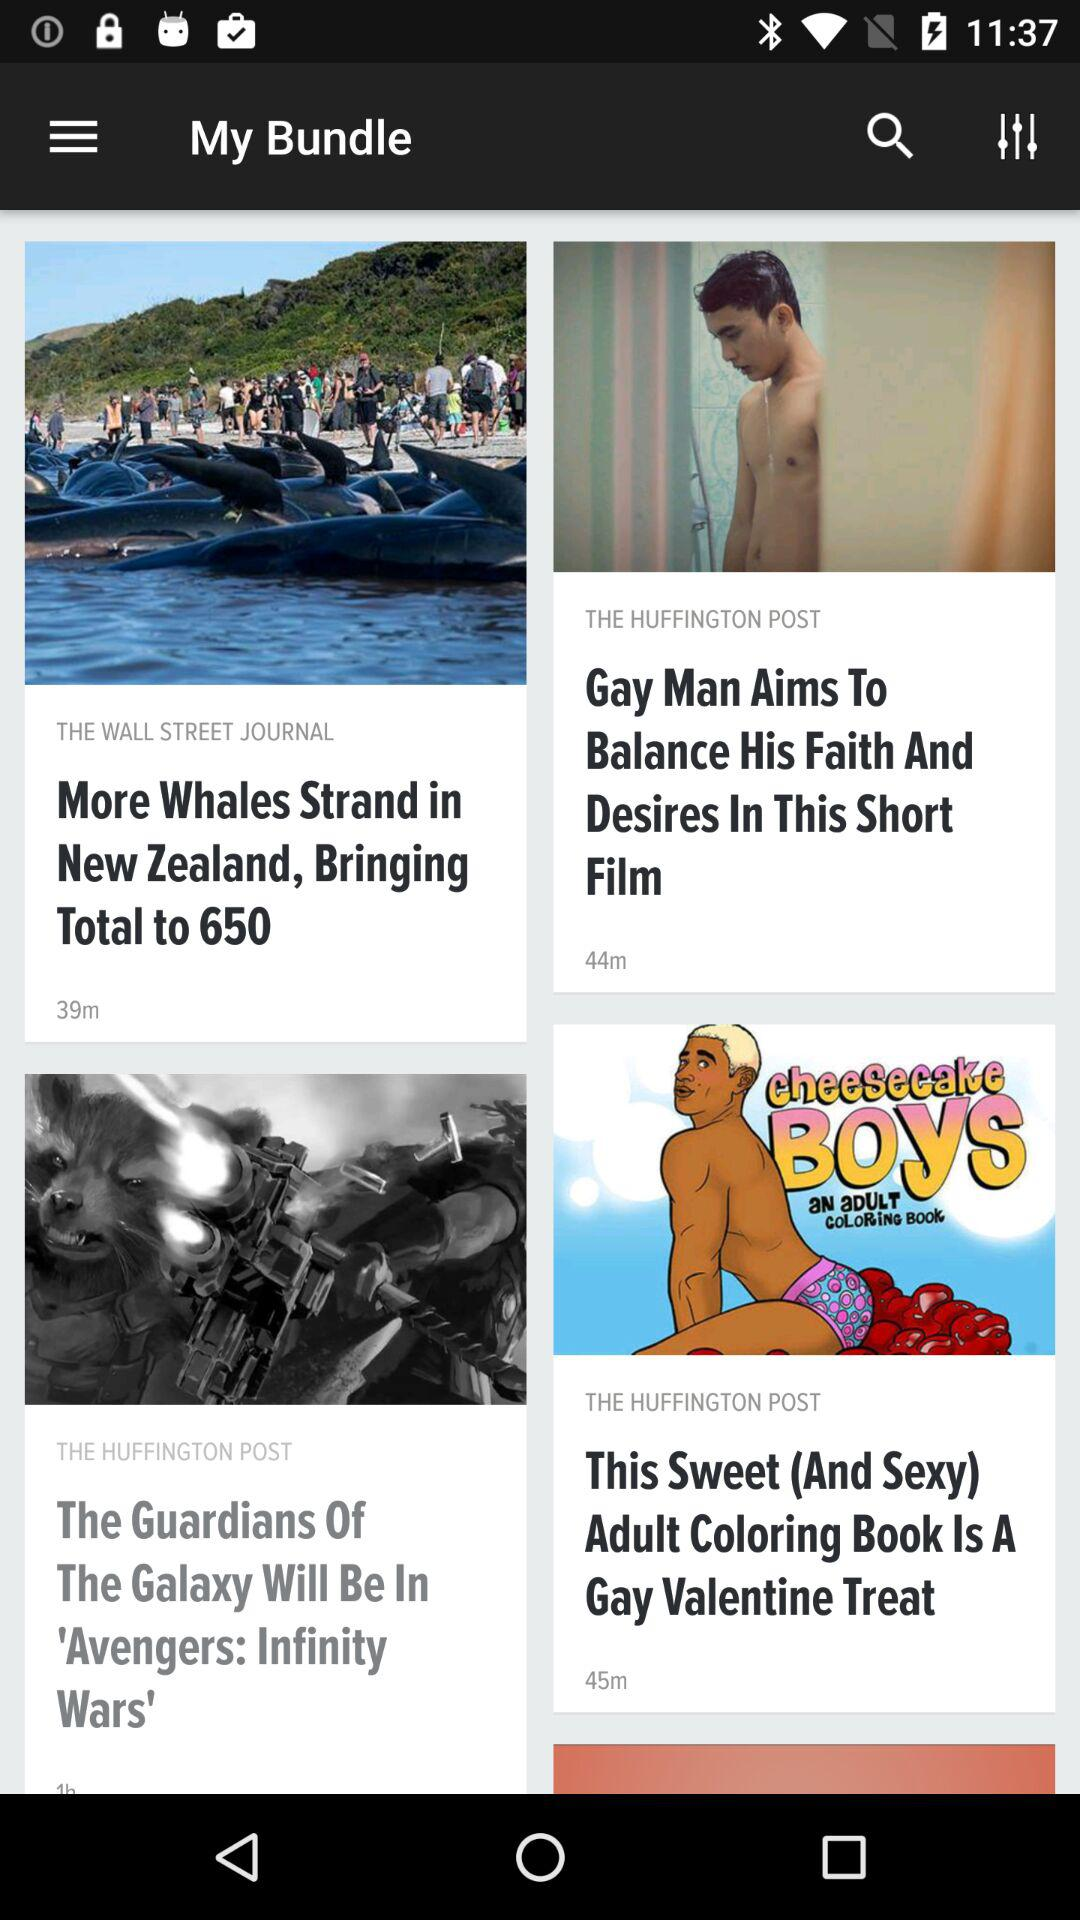How many more articles are there from The Huffington Post than The Wall Street Journal?
Answer the question using a single word or phrase. 2 